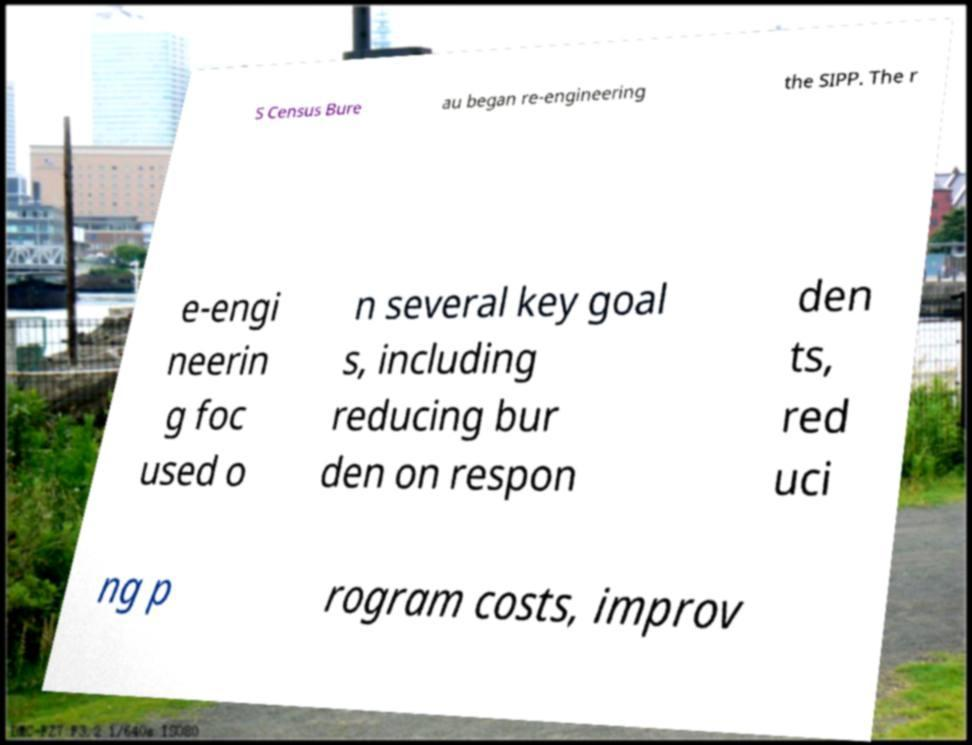I need the written content from this picture converted into text. Can you do that? S Census Bure au began re-engineering the SIPP. The r e-engi neerin g foc used o n several key goal s, including reducing bur den on respon den ts, red uci ng p rogram costs, improv 